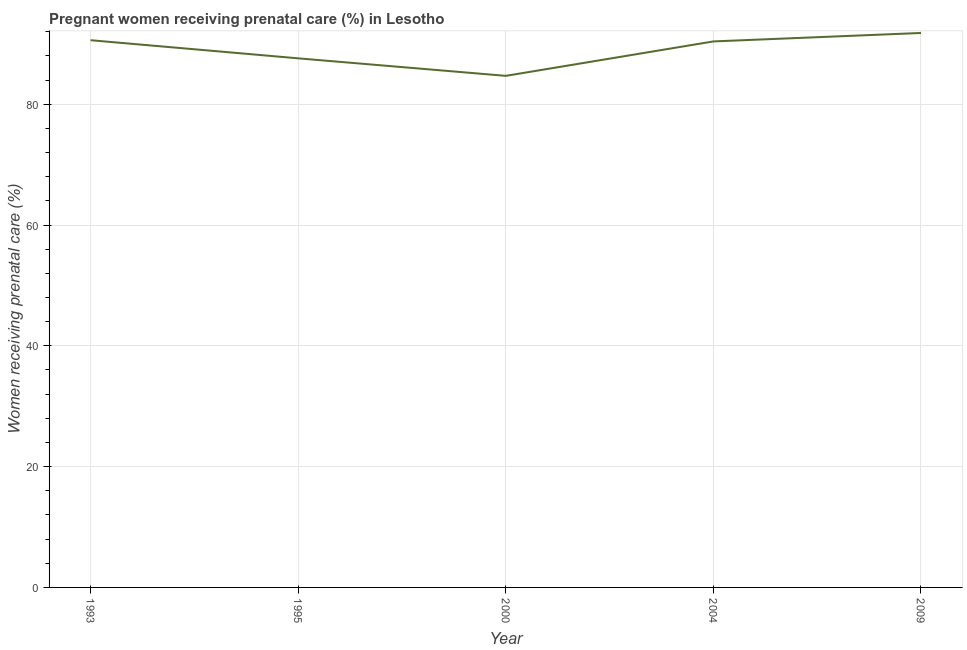What is the percentage of pregnant women receiving prenatal care in 2009?
Offer a terse response. 91.8. Across all years, what is the maximum percentage of pregnant women receiving prenatal care?
Make the answer very short. 91.8. Across all years, what is the minimum percentage of pregnant women receiving prenatal care?
Your answer should be very brief. 84.7. In which year was the percentage of pregnant women receiving prenatal care maximum?
Your response must be concise. 2009. In which year was the percentage of pregnant women receiving prenatal care minimum?
Your answer should be very brief. 2000. What is the sum of the percentage of pregnant women receiving prenatal care?
Your answer should be compact. 445.1. What is the difference between the percentage of pregnant women receiving prenatal care in 1995 and 2000?
Your response must be concise. 2.9. What is the average percentage of pregnant women receiving prenatal care per year?
Ensure brevity in your answer.  89.02. What is the median percentage of pregnant women receiving prenatal care?
Provide a succinct answer. 90.4. In how many years, is the percentage of pregnant women receiving prenatal care greater than 16 %?
Offer a terse response. 5. What is the ratio of the percentage of pregnant women receiving prenatal care in 1993 to that in 2009?
Make the answer very short. 0.99. Is the percentage of pregnant women receiving prenatal care in 1993 less than that in 2009?
Your response must be concise. Yes. Is the difference between the percentage of pregnant women receiving prenatal care in 2000 and 2009 greater than the difference between any two years?
Provide a succinct answer. Yes. What is the difference between the highest and the second highest percentage of pregnant women receiving prenatal care?
Make the answer very short. 1.2. Is the sum of the percentage of pregnant women receiving prenatal care in 1995 and 2000 greater than the maximum percentage of pregnant women receiving prenatal care across all years?
Offer a terse response. Yes. What is the difference between the highest and the lowest percentage of pregnant women receiving prenatal care?
Your answer should be very brief. 7.1. In how many years, is the percentage of pregnant women receiving prenatal care greater than the average percentage of pregnant women receiving prenatal care taken over all years?
Your answer should be very brief. 3. Does the percentage of pregnant women receiving prenatal care monotonically increase over the years?
Your answer should be very brief. No. Are the values on the major ticks of Y-axis written in scientific E-notation?
Make the answer very short. No. What is the title of the graph?
Your answer should be compact. Pregnant women receiving prenatal care (%) in Lesotho. What is the label or title of the Y-axis?
Make the answer very short. Women receiving prenatal care (%). What is the Women receiving prenatal care (%) of 1993?
Offer a very short reply. 90.6. What is the Women receiving prenatal care (%) in 1995?
Offer a terse response. 87.6. What is the Women receiving prenatal care (%) in 2000?
Provide a short and direct response. 84.7. What is the Women receiving prenatal care (%) in 2004?
Your answer should be compact. 90.4. What is the Women receiving prenatal care (%) in 2009?
Ensure brevity in your answer.  91.8. What is the difference between the Women receiving prenatal care (%) in 1993 and 1995?
Your answer should be very brief. 3. What is the difference between the Women receiving prenatal care (%) in 1993 and 2004?
Give a very brief answer. 0.2. What is the difference between the Women receiving prenatal care (%) in 1995 and 2000?
Give a very brief answer. 2.9. What is the difference between the Women receiving prenatal care (%) in 1995 and 2004?
Your answer should be compact. -2.8. What is the difference between the Women receiving prenatal care (%) in 1995 and 2009?
Offer a very short reply. -4.2. What is the difference between the Women receiving prenatal care (%) in 2000 and 2004?
Give a very brief answer. -5.7. What is the ratio of the Women receiving prenatal care (%) in 1993 to that in 1995?
Your response must be concise. 1.03. What is the ratio of the Women receiving prenatal care (%) in 1993 to that in 2000?
Your response must be concise. 1.07. What is the ratio of the Women receiving prenatal care (%) in 1995 to that in 2000?
Offer a terse response. 1.03. What is the ratio of the Women receiving prenatal care (%) in 1995 to that in 2004?
Your answer should be very brief. 0.97. What is the ratio of the Women receiving prenatal care (%) in 1995 to that in 2009?
Make the answer very short. 0.95. What is the ratio of the Women receiving prenatal care (%) in 2000 to that in 2004?
Your answer should be compact. 0.94. What is the ratio of the Women receiving prenatal care (%) in 2000 to that in 2009?
Your response must be concise. 0.92. What is the ratio of the Women receiving prenatal care (%) in 2004 to that in 2009?
Keep it short and to the point. 0.98. 